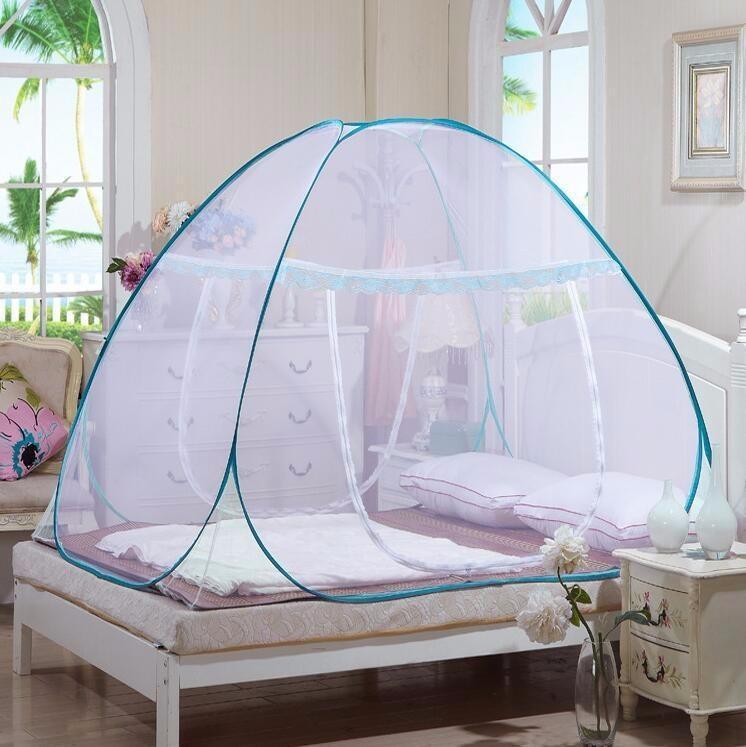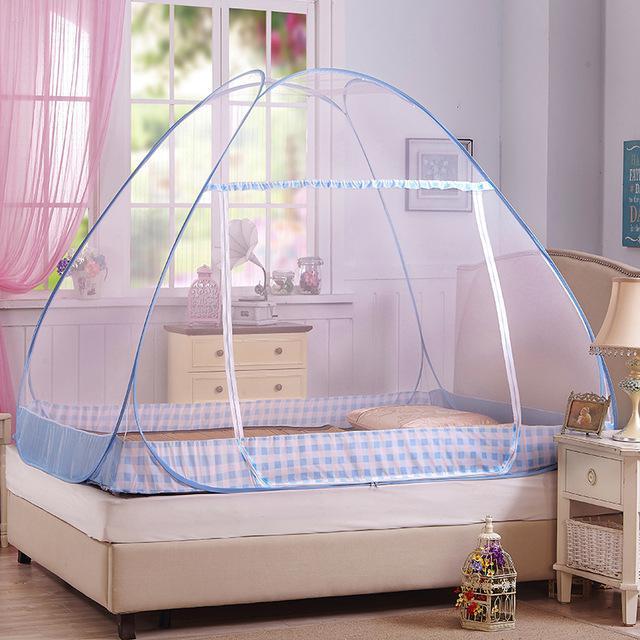The first image is the image on the left, the second image is the image on the right. Analyze the images presented: Is the assertion "There are two tent canopies with at least one with blue trim that has a pattern around the bottom of the tent." valid? Answer yes or no. Yes. 